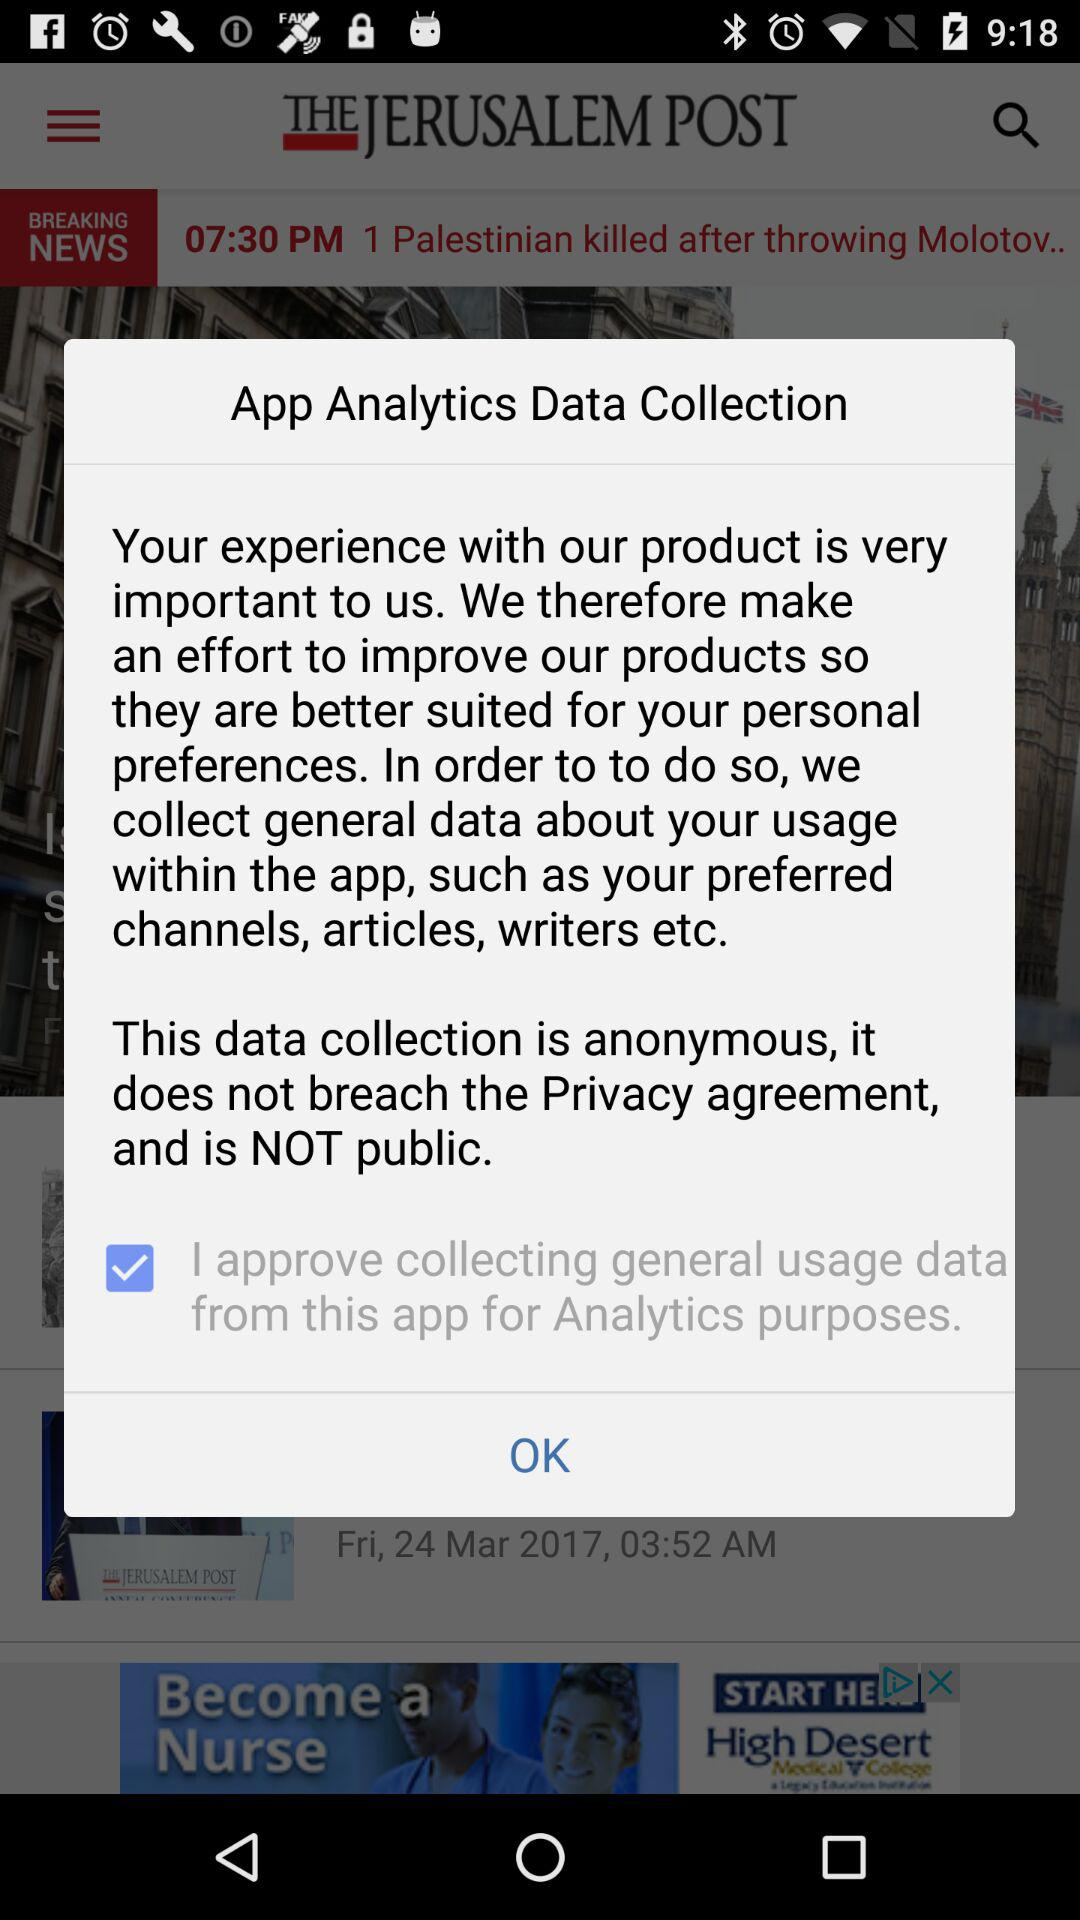What is the status of "I approve collecting general usage data from this app for Analytics purposes"? The status is "on". 